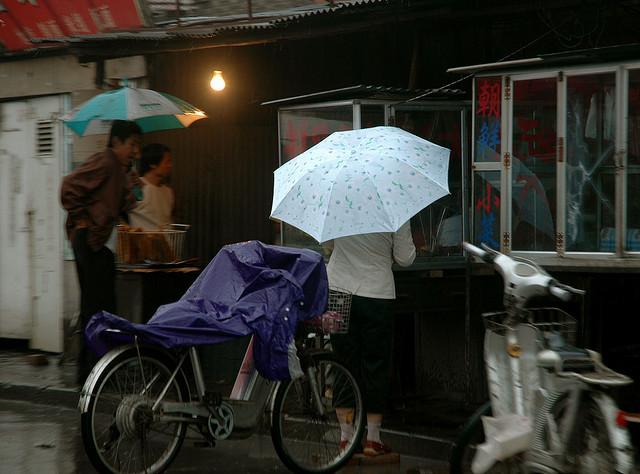Is this taken at night?
Be succinct. No. What is being used to hold the first umbrella up?
Be succinct. Head. What is the weather like?
Concise answer only. Rainy. Who does the bike with the purple tarp over it most likely belong to?
Keep it brief. Man. 